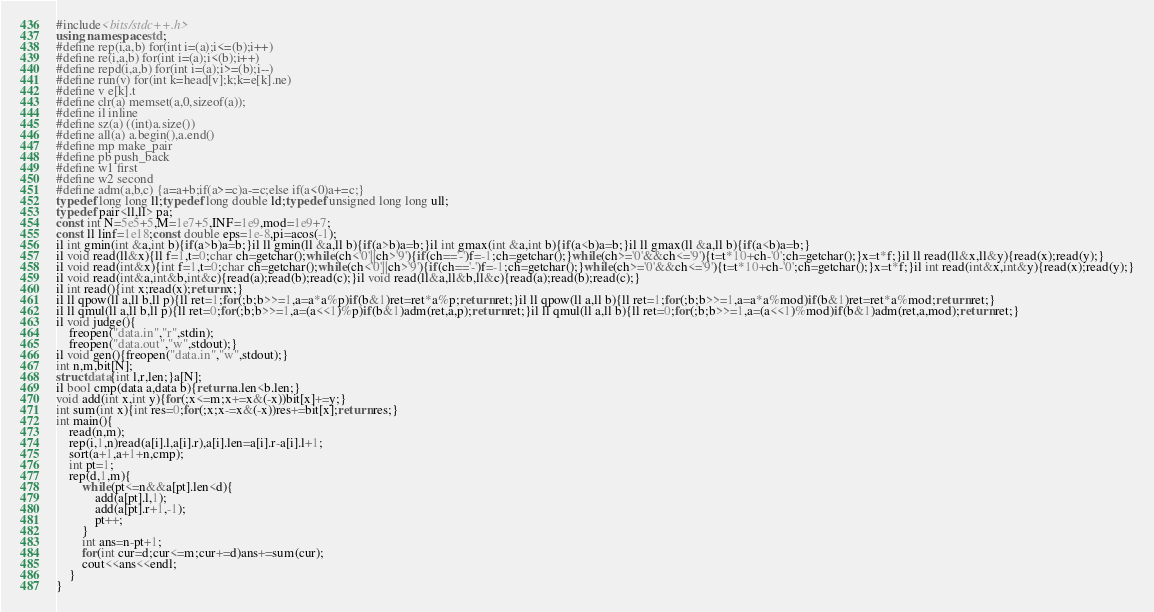<code> <loc_0><loc_0><loc_500><loc_500><_C++_>#include<bits/stdc++.h>
using namespace std;
#define rep(i,a,b) for(int i=(a);i<=(b);i++)
#define re(i,a,b) for(int i=(a);i<(b);i++)
#define repd(i,a,b) for(int i=(a);i>=(b);i--)
#define run(v) for(int k=head[v];k;k=e[k].ne)
#define v e[k].t
#define clr(a) memset(a,0,sizeof(a));
#define il inline
#define sz(a) ((int)a.size())
#define all(a) a.begin(),a.end()
#define mp make_pair
#define pb push_back 
#define w1 first
#define w2 second
#define adm(a,b,c) {a=a+b;if(a>=c)a-=c;else if(a<0)a+=c;}
typedef long long ll;typedef long double ld;typedef unsigned long long ull;
typedef pair<ll,ll> pa;
const int N=5e5+5,M=1e7+5,INF=1e9,mod=1e9+7;
const ll linf=1e18;const double eps=1e-8,pi=acos(-1);
il int gmin(int &a,int b){if(a>b)a=b;}il ll gmin(ll &a,ll b){if(a>b)a=b;}il int gmax(int &a,int b){if(a<b)a=b;}il ll gmax(ll &a,ll b){if(a<b)a=b;}
il void read(ll&x){ll f=1,t=0;char ch=getchar();while(ch<'0'||ch>'9'){if(ch=='-')f=-1;ch=getchar();}while(ch>='0'&&ch<='9'){t=t*10+ch-'0';ch=getchar();}x=t*f;}il ll read(ll&x,ll&y){read(x);read(y);}
il void read(int&x){int f=1,t=0;char ch=getchar();while(ch<'0'||ch>'9'){if(ch=='-')f=-1;ch=getchar();}while(ch>='0'&&ch<='9'){t=t*10+ch-'0';ch=getchar();}x=t*f;}il int read(int&x,int&y){read(x);read(y);}
il void read(int&a,int&b,int&c){read(a);read(b);read(c);}il void read(ll&a,ll&b,ll&c){read(a);read(b);read(c);}
il int read(){int x;read(x);return x;}
il ll qpow(ll a,ll b,ll p){ll ret=1;for(;b;b>>=1,a=a*a%p)if(b&1)ret=ret*a%p;return ret;}il ll qpow(ll a,ll b){ll ret=1;for(;b;b>>=1,a=a*a%mod)if(b&1)ret=ret*a%mod;return ret;}
il ll qmul(ll a,ll b,ll p){ll ret=0;for(;b;b>>=1,a=(a<<1)%p)if(b&1)adm(ret,a,p);return ret;}il ll qmul(ll a,ll b){ll ret=0;for(;b;b>>=1,a=(a<<1)%mod)if(b&1)adm(ret,a,mod);return ret;}
il void judge(){
	freopen("data.in","r",stdin);
	freopen("data.out","w",stdout);}
il void gen(){freopen("data.in","w",stdout);}
int n,m,bit[N];
struct data{int l,r,len;}a[N];
il bool cmp(data a,data b){return a.len<b.len;}
void add(int x,int y){for(;x<=m;x+=x&(-x))bit[x]+=y;}
int sum(int x){int res=0;for(;x;x-=x&(-x))res+=bit[x];return res;}
int main(){
	read(n,m);
	rep(i,1,n)read(a[i].l,a[i].r),a[i].len=a[i].r-a[i].l+1;
	sort(a+1,a+1+n,cmp);
	int pt=1;
	rep(d,1,m){
		while(pt<=n&&a[pt].len<d){
			add(a[pt].l,1);
			add(a[pt].r+1,-1);		
			pt++;
		}
		int ans=n-pt+1;
		for(int cur=d;cur<=m;cur+=d)ans+=sum(cur);
		cout<<ans<<endl;
	}
}</code> 